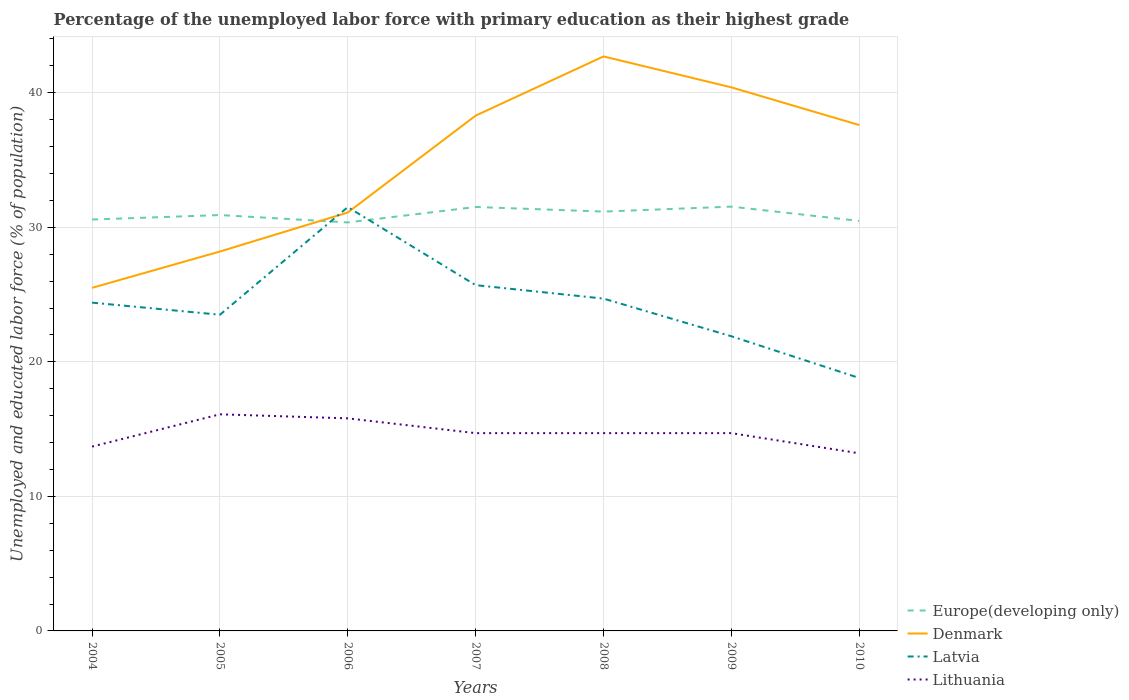How many different coloured lines are there?
Make the answer very short. 4. Does the line corresponding to Europe(developing only) intersect with the line corresponding to Latvia?
Your answer should be very brief. Yes. Across all years, what is the maximum percentage of the unemployed labor force with primary education in Europe(developing only)?
Provide a succinct answer. 30.36. In which year was the percentage of the unemployed labor force with primary education in Europe(developing only) maximum?
Provide a short and direct response. 2006. What is the total percentage of the unemployed labor force with primary education in Latvia in the graph?
Ensure brevity in your answer.  -0.3. What is the difference between the highest and the second highest percentage of the unemployed labor force with primary education in Europe(developing only)?
Offer a very short reply. 1.17. What is the difference between the highest and the lowest percentage of the unemployed labor force with primary education in Europe(developing only)?
Make the answer very short. 3. How many lines are there?
Offer a terse response. 4. How many years are there in the graph?
Provide a short and direct response. 7. What is the difference between two consecutive major ticks on the Y-axis?
Your answer should be compact. 10. Are the values on the major ticks of Y-axis written in scientific E-notation?
Offer a very short reply. No. Does the graph contain grids?
Your answer should be very brief. Yes. Where does the legend appear in the graph?
Your answer should be very brief. Bottom right. What is the title of the graph?
Your answer should be very brief. Percentage of the unemployed labor force with primary education as their highest grade. Does "Jordan" appear as one of the legend labels in the graph?
Your answer should be very brief. No. What is the label or title of the Y-axis?
Keep it short and to the point. Unemployed and educated labor force (% of population). What is the Unemployed and educated labor force (% of population) in Europe(developing only) in 2004?
Your answer should be compact. 30.58. What is the Unemployed and educated labor force (% of population) in Latvia in 2004?
Your answer should be compact. 24.4. What is the Unemployed and educated labor force (% of population) in Lithuania in 2004?
Provide a succinct answer. 13.7. What is the Unemployed and educated labor force (% of population) of Europe(developing only) in 2005?
Provide a short and direct response. 30.91. What is the Unemployed and educated labor force (% of population) of Denmark in 2005?
Offer a terse response. 28.2. What is the Unemployed and educated labor force (% of population) in Latvia in 2005?
Ensure brevity in your answer.  23.5. What is the Unemployed and educated labor force (% of population) in Lithuania in 2005?
Provide a short and direct response. 16.1. What is the Unemployed and educated labor force (% of population) in Europe(developing only) in 2006?
Keep it short and to the point. 30.36. What is the Unemployed and educated labor force (% of population) of Denmark in 2006?
Your response must be concise. 31.1. What is the Unemployed and educated labor force (% of population) of Latvia in 2006?
Your answer should be very brief. 31.5. What is the Unemployed and educated labor force (% of population) in Lithuania in 2006?
Provide a succinct answer. 15.8. What is the Unemployed and educated labor force (% of population) in Europe(developing only) in 2007?
Provide a succinct answer. 31.51. What is the Unemployed and educated labor force (% of population) of Denmark in 2007?
Keep it short and to the point. 38.3. What is the Unemployed and educated labor force (% of population) in Latvia in 2007?
Your answer should be very brief. 25.7. What is the Unemployed and educated labor force (% of population) of Lithuania in 2007?
Your response must be concise. 14.7. What is the Unemployed and educated labor force (% of population) of Europe(developing only) in 2008?
Provide a short and direct response. 31.17. What is the Unemployed and educated labor force (% of population) of Denmark in 2008?
Your answer should be very brief. 42.7. What is the Unemployed and educated labor force (% of population) in Latvia in 2008?
Keep it short and to the point. 24.7. What is the Unemployed and educated labor force (% of population) in Lithuania in 2008?
Keep it short and to the point. 14.7. What is the Unemployed and educated labor force (% of population) of Europe(developing only) in 2009?
Keep it short and to the point. 31.54. What is the Unemployed and educated labor force (% of population) in Denmark in 2009?
Your answer should be compact. 40.4. What is the Unemployed and educated labor force (% of population) in Latvia in 2009?
Your response must be concise. 21.9. What is the Unemployed and educated labor force (% of population) in Lithuania in 2009?
Your answer should be very brief. 14.7. What is the Unemployed and educated labor force (% of population) in Europe(developing only) in 2010?
Offer a very short reply. 30.47. What is the Unemployed and educated labor force (% of population) of Denmark in 2010?
Ensure brevity in your answer.  37.6. What is the Unemployed and educated labor force (% of population) in Latvia in 2010?
Offer a very short reply. 18.8. What is the Unemployed and educated labor force (% of population) in Lithuania in 2010?
Make the answer very short. 13.2. Across all years, what is the maximum Unemployed and educated labor force (% of population) in Europe(developing only)?
Ensure brevity in your answer.  31.54. Across all years, what is the maximum Unemployed and educated labor force (% of population) in Denmark?
Offer a very short reply. 42.7. Across all years, what is the maximum Unemployed and educated labor force (% of population) in Latvia?
Your answer should be very brief. 31.5. Across all years, what is the maximum Unemployed and educated labor force (% of population) in Lithuania?
Keep it short and to the point. 16.1. Across all years, what is the minimum Unemployed and educated labor force (% of population) of Europe(developing only)?
Your answer should be compact. 30.36. Across all years, what is the minimum Unemployed and educated labor force (% of population) of Denmark?
Provide a succinct answer. 25.5. Across all years, what is the minimum Unemployed and educated labor force (% of population) in Latvia?
Ensure brevity in your answer.  18.8. Across all years, what is the minimum Unemployed and educated labor force (% of population) in Lithuania?
Ensure brevity in your answer.  13.2. What is the total Unemployed and educated labor force (% of population) in Europe(developing only) in the graph?
Offer a terse response. 216.53. What is the total Unemployed and educated labor force (% of population) in Denmark in the graph?
Give a very brief answer. 243.8. What is the total Unemployed and educated labor force (% of population) in Latvia in the graph?
Make the answer very short. 170.5. What is the total Unemployed and educated labor force (% of population) in Lithuania in the graph?
Ensure brevity in your answer.  102.9. What is the difference between the Unemployed and educated labor force (% of population) of Europe(developing only) in 2004 and that in 2005?
Provide a succinct answer. -0.33. What is the difference between the Unemployed and educated labor force (% of population) in Latvia in 2004 and that in 2005?
Offer a very short reply. 0.9. What is the difference between the Unemployed and educated labor force (% of population) of Europe(developing only) in 2004 and that in 2006?
Provide a succinct answer. 0.22. What is the difference between the Unemployed and educated labor force (% of population) in Denmark in 2004 and that in 2006?
Your answer should be very brief. -5.6. What is the difference between the Unemployed and educated labor force (% of population) of Latvia in 2004 and that in 2006?
Offer a very short reply. -7.1. What is the difference between the Unemployed and educated labor force (% of population) in Lithuania in 2004 and that in 2006?
Your answer should be compact. -2.1. What is the difference between the Unemployed and educated labor force (% of population) of Europe(developing only) in 2004 and that in 2007?
Provide a succinct answer. -0.93. What is the difference between the Unemployed and educated labor force (% of population) of Lithuania in 2004 and that in 2007?
Your response must be concise. -1. What is the difference between the Unemployed and educated labor force (% of population) in Europe(developing only) in 2004 and that in 2008?
Your answer should be compact. -0.59. What is the difference between the Unemployed and educated labor force (% of population) in Denmark in 2004 and that in 2008?
Give a very brief answer. -17.2. What is the difference between the Unemployed and educated labor force (% of population) in Latvia in 2004 and that in 2008?
Provide a succinct answer. -0.3. What is the difference between the Unemployed and educated labor force (% of population) in Lithuania in 2004 and that in 2008?
Provide a succinct answer. -1. What is the difference between the Unemployed and educated labor force (% of population) in Europe(developing only) in 2004 and that in 2009?
Give a very brief answer. -0.96. What is the difference between the Unemployed and educated labor force (% of population) in Denmark in 2004 and that in 2009?
Make the answer very short. -14.9. What is the difference between the Unemployed and educated labor force (% of population) in Lithuania in 2004 and that in 2009?
Provide a succinct answer. -1. What is the difference between the Unemployed and educated labor force (% of population) in Europe(developing only) in 2004 and that in 2010?
Keep it short and to the point. 0.1. What is the difference between the Unemployed and educated labor force (% of population) of Lithuania in 2004 and that in 2010?
Offer a very short reply. 0.5. What is the difference between the Unemployed and educated labor force (% of population) in Europe(developing only) in 2005 and that in 2006?
Ensure brevity in your answer.  0.55. What is the difference between the Unemployed and educated labor force (% of population) of Denmark in 2005 and that in 2006?
Ensure brevity in your answer.  -2.9. What is the difference between the Unemployed and educated labor force (% of population) in Latvia in 2005 and that in 2006?
Your answer should be very brief. -8. What is the difference between the Unemployed and educated labor force (% of population) of Europe(developing only) in 2005 and that in 2007?
Your answer should be very brief. -0.6. What is the difference between the Unemployed and educated labor force (% of population) in Lithuania in 2005 and that in 2007?
Provide a succinct answer. 1.4. What is the difference between the Unemployed and educated labor force (% of population) of Europe(developing only) in 2005 and that in 2008?
Provide a succinct answer. -0.26. What is the difference between the Unemployed and educated labor force (% of population) of Denmark in 2005 and that in 2008?
Make the answer very short. -14.5. What is the difference between the Unemployed and educated labor force (% of population) of Europe(developing only) in 2005 and that in 2009?
Offer a very short reply. -0.63. What is the difference between the Unemployed and educated labor force (% of population) of Latvia in 2005 and that in 2009?
Offer a terse response. 1.6. What is the difference between the Unemployed and educated labor force (% of population) of Europe(developing only) in 2005 and that in 2010?
Your response must be concise. 0.44. What is the difference between the Unemployed and educated labor force (% of population) in Denmark in 2005 and that in 2010?
Your answer should be very brief. -9.4. What is the difference between the Unemployed and educated labor force (% of population) in Latvia in 2005 and that in 2010?
Give a very brief answer. 4.7. What is the difference between the Unemployed and educated labor force (% of population) of Lithuania in 2005 and that in 2010?
Provide a short and direct response. 2.9. What is the difference between the Unemployed and educated labor force (% of population) in Europe(developing only) in 2006 and that in 2007?
Offer a terse response. -1.15. What is the difference between the Unemployed and educated labor force (% of population) of Latvia in 2006 and that in 2007?
Make the answer very short. 5.8. What is the difference between the Unemployed and educated labor force (% of population) of Lithuania in 2006 and that in 2007?
Offer a terse response. 1.1. What is the difference between the Unemployed and educated labor force (% of population) of Europe(developing only) in 2006 and that in 2008?
Provide a succinct answer. -0.81. What is the difference between the Unemployed and educated labor force (% of population) in Denmark in 2006 and that in 2008?
Make the answer very short. -11.6. What is the difference between the Unemployed and educated labor force (% of population) in Latvia in 2006 and that in 2008?
Your response must be concise. 6.8. What is the difference between the Unemployed and educated labor force (% of population) in Europe(developing only) in 2006 and that in 2009?
Make the answer very short. -1.17. What is the difference between the Unemployed and educated labor force (% of population) of Latvia in 2006 and that in 2009?
Provide a succinct answer. 9.6. What is the difference between the Unemployed and educated labor force (% of population) of Lithuania in 2006 and that in 2009?
Ensure brevity in your answer.  1.1. What is the difference between the Unemployed and educated labor force (% of population) in Europe(developing only) in 2006 and that in 2010?
Offer a very short reply. -0.11. What is the difference between the Unemployed and educated labor force (% of population) in Europe(developing only) in 2007 and that in 2008?
Give a very brief answer. 0.34. What is the difference between the Unemployed and educated labor force (% of population) in Lithuania in 2007 and that in 2008?
Offer a terse response. 0. What is the difference between the Unemployed and educated labor force (% of population) in Europe(developing only) in 2007 and that in 2009?
Offer a very short reply. -0.03. What is the difference between the Unemployed and educated labor force (% of population) of Denmark in 2007 and that in 2009?
Provide a short and direct response. -2.1. What is the difference between the Unemployed and educated labor force (% of population) of Latvia in 2007 and that in 2009?
Your response must be concise. 3.8. What is the difference between the Unemployed and educated labor force (% of population) of Lithuania in 2007 and that in 2009?
Give a very brief answer. 0. What is the difference between the Unemployed and educated labor force (% of population) of Europe(developing only) in 2007 and that in 2010?
Make the answer very short. 1.04. What is the difference between the Unemployed and educated labor force (% of population) of Lithuania in 2007 and that in 2010?
Give a very brief answer. 1.5. What is the difference between the Unemployed and educated labor force (% of population) of Europe(developing only) in 2008 and that in 2009?
Keep it short and to the point. -0.37. What is the difference between the Unemployed and educated labor force (% of population) in Lithuania in 2008 and that in 2009?
Keep it short and to the point. 0. What is the difference between the Unemployed and educated labor force (% of population) of Europe(developing only) in 2008 and that in 2010?
Give a very brief answer. 0.69. What is the difference between the Unemployed and educated labor force (% of population) in Latvia in 2008 and that in 2010?
Provide a short and direct response. 5.9. What is the difference between the Unemployed and educated labor force (% of population) in Lithuania in 2008 and that in 2010?
Give a very brief answer. 1.5. What is the difference between the Unemployed and educated labor force (% of population) in Europe(developing only) in 2009 and that in 2010?
Ensure brevity in your answer.  1.06. What is the difference between the Unemployed and educated labor force (% of population) of Lithuania in 2009 and that in 2010?
Provide a succinct answer. 1.5. What is the difference between the Unemployed and educated labor force (% of population) of Europe(developing only) in 2004 and the Unemployed and educated labor force (% of population) of Denmark in 2005?
Your answer should be very brief. 2.38. What is the difference between the Unemployed and educated labor force (% of population) in Europe(developing only) in 2004 and the Unemployed and educated labor force (% of population) in Latvia in 2005?
Offer a terse response. 7.08. What is the difference between the Unemployed and educated labor force (% of population) in Europe(developing only) in 2004 and the Unemployed and educated labor force (% of population) in Lithuania in 2005?
Provide a short and direct response. 14.48. What is the difference between the Unemployed and educated labor force (% of population) of Denmark in 2004 and the Unemployed and educated labor force (% of population) of Lithuania in 2005?
Ensure brevity in your answer.  9.4. What is the difference between the Unemployed and educated labor force (% of population) of Europe(developing only) in 2004 and the Unemployed and educated labor force (% of population) of Denmark in 2006?
Offer a very short reply. -0.52. What is the difference between the Unemployed and educated labor force (% of population) of Europe(developing only) in 2004 and the Unemployed and educated labor force (% of population) of Latvia in 2006?
Keep it short and to the point. -0.92. What is the difference between the Unemployed and educated labor force (% of population) in Europe(developing only) in 2004 and the Unemployed and educated labor force (% of population) in Lithuania in 2006?
Ensure brevity in your answer.  14.78. What is the difference between the Unemployed and educated labor force (% of population) of Denmark in 2004 and the Unemployed and educated labor force (% of population) of Latvia in 2006?
Your response must be concise. -6. What is the difference between the Unemployed and educated labor force (% of population) of Denmark in 2004 and the Unemployed and educated labor force (% of population) of Lithuania in 2006?
Provide a short and direct response. 9.7. What is the difference between the Unemployed and educated labor force (% of population) in Europe(developing only) in 2004 and the Unemployed and educated labor force (% of population) in Denmark in 2007?
Give a very brief answer. -7.72. What is the difference between the Unemployed and educated labor force (% of population) of Europe(developing only) in 2004 and the Unemployed and educated labor force (% of population) of Latvia in 2007?
Provide a short and direct response. 4.88. What is the difference between the Unemployed and educated labor force (% of population) of Europe(developing only) in 2004 and the Unemployed and educated labor force (% of population) of Lithuania in 2007?
Your answer should be very brief. 15.88. What is the difference between the Unemployed and educated labor force (% of population) in Denmark in 2004 and the Unemployed and educated labor force (% of population) in Latvia in 2007?
Keep it short and to the point. -0.2. What is the difference between the Unemployed and educated labor force (% of population) in Denmark in 2004 and the Unemployed and educated labor force (% of population) in Lithuania in 2007?
Your answer should be very brief. 10.8. What is the difference between the Unemployed and educated labor force (% of population) of Latvia in 2004 and the Unemployed and educated labor force (% of population) of Lithuania in 2007?
Keep it short and to the point. 9.7. What is the difference between the Unemployed and educated labor force (% of population) of Europe(developing only) in 2004 and the Unemployed and educated labor force (% of population) of Denmark in 2008?
Ensure brevity in your answer.  -12.12. What is the difference between the Unemployed and educated labor force (% of population) of Europe(developing only) in 2004 and the Unemployed and educated labor force (% of population) of Latvia in 2008?
Provide a short and direct response. 5.88. What is the difference between the Unemployed and educated labor force (% of population) of Europe(developing only) in 2004 and the Unemployed and educated labor force (% of population) of Lithuania in 2008?
Your response must be concise. 15.88. What is the difference between the Unemployed and educated labor force (% of population) of Europe(developing only) in 2004 and the Unemployed and educated labor force (% of population) of Denmark in 2009?
Your answer should be very brief. -9.82. What is the difference between the Unemployed and educated labor force (% of population) of Europe(developing only) in 2004 and the Unemployed and educated labor force (% of population) of Latvia in 2009?
Provide a short and direct response. 8.68. What is the difference between the Unemployed and educated labor force (% of population) of Europe(developing only) in 2004 and the Unemployed and educated labor force (% of population) of Lithuania in 2009?
Give a very brief answer. 15.88. What is the difference between the Unemployed and educated labor force (% of population) in Europe(developing only) in 2004 and the Unemployed and educated labor force (% of population) in Denmark in 2010?
Your answer should be very brief. -7.02. What is the difference between the Unemployed and educated labor force (% of population) in Europe(developing only) in 2004 and the Unemployed and educated labor force (% of population) in Latvia in 2010?
Your answer should be very brief. 11.78. What is the difference between the Unemployed and educated labor force (% of population) of Europe(developing only) in 2004 and the Unemployed and educated labor force (% of population) of Lithuania in 2010?
Offer a terse response. 17.38. What is the difference between the Unemployed and educated labor force (% of population) in Denmark in 2004 and the Unemployed and educated labor force (% of population) in Latvia in 2010?
Give a very brief answer. 6.7. What is the difference between the Unemployed and educated labor force (% of population) of Europe(developing only) in 2005 and the Unemployed and educated labor force (% of population) of Denmark in 2006?
Offer a terse response. -0.19. What is the difference between the Unemployed and educated labor force (% of population) of Europe(developing only) in 2005 and the Unemployed and educated labor force (% of population) of Latvia in 2006?
Offer a very short reply. -0.59. What is the difference between the Unemployed and educated labor force (% of population) of Europe(developing only) in 2005 and the Unemployed and educated labor force (% of population) of Lithuania in 2006?
Your response must be concise. 15.11. What is the difference between the Unemployed and educated labor force (% of population) of Europe(developing only) in 2005 and the Unemployed and educated labor force (% of population) of Denmark in 2007?
Provide a succinct answer. -7.39. What is the difference between the Unemployed and educated labor force (% of population) in Europe(developing only) in 2005 and the Unemployed and educated labor force (% of population) in Latvia in 2007?
Your response must be concise. 5.21. What is the difference between the Unemployed and educated labor force (% of population) of Europe(developing only) in 2005 and the Unemployed and educated labor force (% of population) of Lithuania in 2007?
Your response must be concise. 16.21. What is the difference between the Unemployed and educated labor force (% of population) of Denmark in 2005 and the Unemployed and educated labor force (% of population) of Latvia in 2007?
Provide a succinct answer. 2.5. What is the difference between the Unemployed and educated labor force (% of population) in Latvia in 2005 and the Unemployed and educated labor force (% of population) in Lithuania in 2007?
Make the answer very short. 8.8. What is the difference between the Unemployed and educated labor force (% of population) of Europe(developing only) in 2005 and the Unemployed and educated labor force (% of population) of Denmark in 2008?
Provide a succinct answer. -11.79. What is the difference between the Unemployed and educated labor force (% of population) of Europe(developing only) in 2005 and the Unemployed and educated labor force (% of population) of Latvia in 2008?
Keep it short and to the point. 6.21. What is the difference between the Unemployed and educated labor force (% of population) of Europe(developing only) in 2005 and the Unemployed and educated labor force (% of population) of Lithuania in 2008?
Keep it short and to the point. 16.21. What is the difference between the Unemployed and educated labor force (% of population) of Denmark in 2005 and the Unemployed and educated labor force (% of population) of Latvia in 2008?
Give a very brief answer. 3.5. What is the difference between the Unemployed and educated labor force (% of population) of Denmark in 2005 and the Unemployed and educated labor force (% of population) of Lithuania in 2008?
Your response must be concise. 13.5. What is the difference between the Unemployed and educated labor force (% of population) in Europe(developing only) in 2005 and the Unemployed and educated labor force (% of population) in Denmark in 2009?
Keep it short and to the point. -9.49. What is the difference between the Unemployed and educated labor force (% of population) in Europe(developing only) in 2005 and the Unemployed and educated labor force (% of population) in Latvia in 2009?
Your response must be concise. 9.01. What is the difference between the Unemployed and educated labor force (% of population) of Europe(developing only) in 2005 and the Unemployed and educated labor force (% of population) of Lithuania in 2009?
Give a very brief answer. 16.21. What is the difference between the Unemployed and educated labor force (% of population) in Denmark in 2005 and the Unemployed and educated labor force (% of population) in Latvia in 2009?
Your answer should be very brief. 6.3. What is the difference between the Unemployed and educated labor force (% of population) of Denmark in 2005 and the Unemployed and educated labor force (% of population) of Lithuania in 2009?
Make the answer very short. 13.5. What is the difference between the Unemployed and educated labor force (% of population) in Europe(developing only) in 2005 and the Unemployed and educated labor force (% of population) in Denmark in 2010?
Your answer should be very brief. -6.69. What is the difference between the Unemployed and educated labor force (% of population) of Europe(developing only) in 2005 and the Unemployed and educated labor force (% of population) of Latvia in 2010?
Offer a terse response. 12.11. What is the difference between the Unemployed and educated labor force (% of population) in Europe(developing only) in 2005 and the Unemployed and educated labor force (% of population) in Lithuania in 2010?
Your answer should be compact. 17.71. What is the difference between the Unemployed and educated labor force (% of population) of Europe(developing only) in 2006 and the Unemployed and educated labor force (% of population) of Denmark in 2007?
Give a very brief answer. -7.94. What is the difference between the Unemployed and educated labor force (% of population) in Europe(developing only) in 2006 and the Unemployed and educated labor force (% of population) in Latvia in 2007?
Offer a terse response. 4.66. What is the difference between the Unemployed and educated labor force (% of population) of Europe(developing only) in 2006 and the Unemployed and educated labor force (% of population) of Lithuania in 2007?
Provide a succinct answer. 15.66. What is the difference between the Unemployed and educated labor force (% of population) in Denmark in 2006 and the Unemployed and educated labor force (% of population) in Latvia in 2007?
Keep it short and to the point. 5.4. What is the difference between the Unemployed and educated labor force (% of population) in Denmark in 2006 and the Unemployed and educated labor force (% of population) in Lithuania in 2007?
Offer a very short reply. 16.4. What is the difference between the Unemployed and educated labor force (% of population) in Europe(developing only) in 2006 and the Unemployed and educated labor force (% of population) in Denmark in 2008?
Offer a terse response. -12.34. What is the difference between the Unemployed and educated labor force (% of population) of Europe(developing only) in 2006 and the Unemployed and educated labor force (% of population) of Latvia in 2008?
Provide a short and direct response. 5.66. What is the difference between the Unemployed and educated labor force (% of population) in Europe(developing only) in 2006 and the Unemployed and educated labor force (% of population) in Lithuania in 2008?
Your answer should be compact. 15.66. What is the difference between the Unemployed and educated labor force (% of population) in Denmark in 2006 and the Unemployed and educated labor force (% of population) in Latvia in 2008?
Make the answer very short. 6.4. What is the difference between the Unemployed and educated labor force (% of population) of Denmark in 2006 and the Unemployed and educated labor force (% of population) of Lithuania in 2008?
Offer a terse response. 16.4. What is the difference between the Unemployed and educated labor force (% of population) in Europe(developing only) in 2006 and the Unemployed and educated labor force (% of population) in Denmark in 2009?
Make the answer very short. -10.04. What is the difference between the Unemployed and educated labor force (% of population) of Europe(developing only) in 2006 and the Unemployed and educated labor force (% of population) of Latvia in 2009?
Your answer should be compact. 8.46. What is the difference between the Unemployed and educated labor force (% of population) in Europe(developing only) in 2006 and the Unemployed and educated labor force (% of population) in Lithuania in 2009?
Your response must be concise. 15.66. What is the difference between the Unemployed and educated labor force (% of population) of Denmark in 2006 and the Unemployed and educated labor force (% of population) of Latvia in 2009?
Provide a succinct answer. 9.2. What is the difference between the Unemployed and educated labor force (% of population) in Denmark in 2006 and the Unemployed and educated labor force (% of population) in Lithuania in 2009?
Ensure brevity in your answer.  16.4. What is the difference between the Unemployed and educated labor force (% of population) in Latvia in 2006 and the Unemployed and educated labor force (% of population) in Lithuania in 2009?
Make the answer very short. 16.8. What is the difference between the Unemployed and educated labor force (% of population) in Europe(developing only) in 2006 and the Unemployed and educated labor force (% of population) in Denmark in 2010?
Offer a very short reply. -7.24. What is the difference between the Unemployed and educated labor force (% of population) of Europe(developing only) in 2006 and the Unemployed and educated labor force (% of population) of Latvia in 2010?
Keep it short and to the point. 11.56. What is the difference between the Unemployed and educated labor force (% of population) in Europe(developing only) in 2006 and the Unemployed and educated labor force (% of population) in Lithuania in 2010?
Give a very brief answer. 17.16. What is the difference between the Unemployed and educated labor force (% of population) of Denmark in 2006 and the Unemployed and educated labor force (% of population) of Latvia in 2010?
Ensure brevity in your answer.  12.3. What is the difference between the Unemployed and educated labor force (% of population) of Denmark in 2006 and the Unemployed and educated labor force (% of population) of Lithuania in 2010?
Offer a very short reply. 17.9. What is the difference between the Unemployed and educated labor force (% of population) in Latvia in 2006 and the Unemployed and educated labor force (% of population) in Lithuania in 2010?
Your answer should be compact. 18.3. What is the difference between the Unemployed and educated labor force (% of population) in Europe(developing only) in 2007 and the Unemployed and educated labor force (% of population) in Denmark in 2008?
Provide a succinct answer. -11.19. What is the difference between the Unemployed and educated labor force (% of population) in Europe(developing only) in 2007 and the Unemployed and educated labor force (% of population) in Latvia in 2008?
Your answer should be compact. 6.81. What is the difference between the Unemployed and educated labor force (% of population) of Europe(developing only) in 2007 and the Unemployed and educated labor force (% of population) of Lithuania in 2008?
Your answer should be compact. 16.81. What is the difference between the Unemployed and educated labor force (% of population) of Denmark in 2007 and the Unemployed and educated labor force (% of population) of Latvia in 2008?
Provide a succinct answer. 13.6. What is the difference between the Unemployed and educated labor force (% of population) in Denmark in 2007 and the Unemployed and educated labor force (% of population) in Lithuania in 2008?
Give a very brief answer. 23.6. What is the difference between the Unemployed and educated labor force (% of population) of Europe(developing only) in 2007 and the Unemployed and educated labor force (% of population) of Denmark in 2009?
Your response must be concise. -8.89. What is the difference between the Unemployed and educated labor force (% of population) of Europe(developing only) in 2007 and the Unemployed and educated labor force (% of population) of Latvia in 2009?
Offer a terse response. 9.61. What is the difference between the Unemployed and educated labor force (% of population) in Europe(developing only) in 2007 and the Unemployed and educated labor force (% of population) in Lithuania in 2009?
Give a very brief answer. 16.81. What is the difference between the Unemployed and educated labor force (% of population) in Denmark in 2007 and the Unemployed and educated labor force (% of population) in Lithuania in 2009?
Provide a short and direct response. 23.6. What is the difference between the Unemployed and educated labor force (% of population) in Latvia in 2007 and the Unemployed and educated labor force (% of population) in Lithuania in 2009?
Provide a succinct answer. 11. What is the difference between the Unemployed and educated labor force (% of population) in Europe(developing only) in 2007 and the Unemployed and educated labor force (% of population) in Denmark in 2010?
Provide a short and direct response. -6.09. What is the difference between the Unemployed and educated labor force (% of population) of Europe(developing only) in 2007 and the Unemployed and educated labor force (% of population) of Latvia in 2010?
Ensure brevity in your answer.  12.71. What is the difference between the Unemployed and educated labor force (% of population) in Europe(developing only) in 2007 and the Unemployed and educated labor force (% of population) in Lithuania in 2010?
Ensure brevity in your answer.  18.31. What is the difference between the Unemployed and educated labor force (% of population) of Denmark in 2007 and the Unemployed and educated labor force (% of population) of Latvia in 2010?
Provide a short and direct response. 19.5. What is the difference between the Unemployed and educated labor force (% of population) in Denmark in 2007 and the Unemployed and educated labor force (% of population) in Lithuania in 2010?
Make the answer very short. 25.1. What is the difference between the Unemployed and educated labor force (% of population) in Europe(developing only) in 2008 and the Unemployed and educated labor force (% of population) in Denmark in 2009?
Your response must be concise. -9.23. What is the difference between the Unemployed and educated labor force (% of population) in Europe(developing only) in 2008 and the Unemployed and educated labor force (% of population) in Latvia in 2009?
Make the answer very short. 9.27. What is the difference between the Unemployed and educated labor force (% of population) in Europe(developing only) in 2008 and the Unemployed and educated labor force (% of population) in Lithuania in 2009?
Your answer should be compact. 16.47. What is the difference between the Unemployed and educated labor force (% of population) in Denmark in 2008 and the Unemployed and educated labor force (% of population) in Latvia in 2009?
Provide a short and direct response. 20.8. What is the difference between the Unemployed and educated labor force (% of population) of Europe(developing only) in 2008 and the Unemployed and educated labor force (% of population) of Denmark in 2010?
Your answer should be compact. -6.43. What is the difference between the Unemployed and educated labor force (% of population) of Europe(developing only) in 2008 and the Unemployed and educated labor force (% of population) of Latvia in 2010?
Provide a succinct answer. 12.37. What is the difference between the Unemployed and educated labor force (% of population) of Europe(developing only) in 2008 and the Unemployed and educated labor force (% of population) of Lithuania in 2010?
Your answer should be very brief. 17.97. What is the difference between the Unemployed and educated labor force (% of population) in Denmark in 2008 and the Unemployed and educated labor force (% of population) in Latvia in 2010?
Ensure brevity in your answer.  23.9. What is the difference between the Unemployed and educated labor force (% of population) in Denmark in 2008 and the Unemployed and educated labor force (% of population) in Lithuania in 2010?
Provide a succinct answer. 29.5. What is the difference between the Unemployed and educated labor force (% of population) of Latvia in 2008 and the Unemployed and educated labor force (% of population) of Lithuania in 2010?
Provide a succinct answer. 11.5. What is the difference between the Unemployed and educated labor force (% of population) in Europe(developing only) in 2009 and the Unemployed and educated labor force (% of population) in Denmark in 2010?
Ensure brevity in your answer.  -6.06. What is the difference between the Unemployed and educated labor force (% of population) of Europe(developing only) in 2009 and the Unemployed and educated labor force (% of population) of Latvia in 2010?
Give a very brief answer. 12.74. What is the difference between the Unemployed and educated labor force (% of population) in Europe(developing only) in 2009 and the Unemployed and educated labor force (% of population) in Lithuania in 2010?
Provide a short and direct response. 18.34. What is the difference between the Unemployed and educated labor force (% of population) in Denmark in 2009 and the Unemployed and educated labor force (% of population) in Latvia in 2010?
Your answer should be compact. 21.6. What is the difference between the Unemployed and educated labor force (% of population) of Denmark in 2009 and the Unemployed and educated labor force (% of population) of Lithuania in 2010?
Ensure brevity in your answer.  27.2. What is the average Unemployed and educated labor force (% of population) of Europe(developing only) per year?
Your response must be concise. 30.93. What is the average Unemployed and educated labor force (% of population) of Denmark per year?
Ensure brevity in your answer.  34.83. What is the average Unemployed and educated labor force (% of population) in Latvia per year?
Offer a terse response. 24.36. What is the average Unemployed and educated labor force (% of population) in Lithuania per year?
Your answer should be very brief. 14.7. In the year 2004, what is the difference between the Unemployed and educated labor force (% of population) of Europe(developing only) and Unemployed and educated labor force (% of population) of Denmark?
Make the answer very short. 5.08. In the year 2004, what is the difference between the Unemployed and educated labor force (% of population) in Europe(developing only) and Unemployed and educated labor force (% of population) in Latvia?
Provide a short and direct response. 6.18. In the year 2004, what is the difference between the Unemployed and educated labor force (% of population) of Europe(developing only) and Unemployed and educated labor force (% of population) of Lithuania?
Give a very brief answer. 16.88. In the year 2004, what is the difference between the Unemployed and educated labor force (% of population) of Latvia and Unemployed and educated labor force (% of population) of Lithuania?
Your answer should be compact. 10.7. In the year 2005, what is the difference between the Unemployed and educated labor force (% of population) in Europe(developing only) and Unemployed and educated labor force (% of population) in Denmark?
Provide a succinct answer. 2.71. In the year 2005, what is the difference between the Unemployed and educated labor force (% of population) of Europe(developing only) and Unemployed and educated labor force (% of population) of Latvia?
Your answer should be very brief. 7.41. In the year 2005, what is the difference between the Unemployed and educated labor force (% of population) in Europe(developing only) and Unemployed and educated labor force (% of population) in Lithuania?
Make the answer very short. 14.81. In the year 2005, what is the difference between the Unemployed and educated labor force (% of population) of Denmark and Unemployed and educated labor force (% of population) of Lithuania?
Provide a succinct answer. 12.1. In the year 2006, what is the difference between the Unemployed and educated labor force (% of population) of Europe(developing only) and Unemployed and educated labor force (% of population) of Denmark?
Ensure brevity in your answer.  -0.74. In the year 2006, what is the difference between the Unemployed and educated labor force (% of population) of Europe(developing only) and Unemployed and educated labor force (% of population) of Latvia?
Keep it short and to the point. -1.14. In the year 2006, what is the difference between the Unemployed and educated labor force (% of population) in Europe(developing only) and Unemployed and educated labor force (% of population) in Lithuania?
Make the answer very short. 14.56. In the year 2006, what is the difference between the Unemployed and educated labor force (% of population) of Denmark and Unemployed and educated labor force (% of population) of Latvia?
Give a very brief answer. -0.4. In the year 2006, what is the difference between the Unemployed and educated labor force (% of population) of Latvia and Unemployed and educated labor force (% of population) of Lithuania?
Give a very brief answer. 15.7. In the year 2007, what is the difference between the Unemployed and educated labor force (% of population) in Europe(developing only) and Unemployed and educated labor force (% of population) in Denmark?
Give a very brief answer. -6.79. In the year 2007, what is the difference between the Unemployed and educated labor force (% of population) in Europe(developing only) and Unemployed and educated labor force (% of population) in Latvia?
Provide a succinct answer. 5.81. In the year 2007, what is the difference between the Unemployed and educated labor force (% of population) in Europe(developing only) and Unemployed and educated labor force (% of population) in Lithuania?
Give a very brief answer. 16.81. In the year 2007, what is the difference between the Unemployed and educated labor force (% of population) of Denmark and Unemployed and educated labor force (% of population) of Lithuania?
Ensure brevity in your answer.  23.6. In the year 2008, what is the difference between the Unemployed and educated labor force (% of population) of Europe(developing only) and Unemployed and educated labor force (% of population) of Denmark?
Provide a short and direct response. -11.53. In the year 2008, what is the difference between the Unemployed and educated labor force (% of population) of Europe(developing only) and Unemployed and educated labor force (% of population) of Latvia?
Provide a succinct answer. 6.47. In the year 2008, what is the difference between the Unemployed and educated labor force (% of population) in Europe(developing only) and Unemployed and educated labor force (% of population) in Lithuania?
Offer a very short reply. 16.47. In the year 2008, what is the difference between the Unemployed and educated labor force (% of population) of Denmark and Unemployed and educated labor force (% of population) of Latvia?
Provide a succinct answer. 18. In the year 2008, what is the difference between the Unemployed and educated labor force (% of population) of Denmark and Unemployed and educated labor force (% of population) of Lithuania?
Offer a very short reply. 28. In the year 2009, what is the difference between the Unemployed and educated labor force (% of population) in Europe(developing only) and Unemployed and educated labor force (% of population) in Denmark?
Ensure brevity in your answer.  -8.86. In the year 2009, what is the difference between the Unemployed and educated labor force (% of population) of Europe(developing only) and Unemployed and educated labor force (% of population) of Latvia?
Make the answer very short. 9.64. In the year 2009, what is the difference between the Unemployed and educated labor force (% of population) in Europe(developing only) and Unemployed and educated labor force (% of population) in Lithuania?
Your answer should be compact. 16.84. In the year 2009, what is the difference between the Unemployed and educated labor force (% of population) in Denmark and Unemployed and educated labor force (% of population) in Lithuania?
Provide a succinct answer. 25.7. In the year 2009, what is the difference between the Unemployed and educated labor force (% of population) in Latvia and Unemployed and educated labor force (% of population) in Lithuania?
Make the answer very short. 7.2. In the year 2010, what is the difference between the Unemployed and educated labor force (% of population) in Europe(developing only) and Unemployed and educated labor force (% of population) in Denmark?
Provide a succinct answer. -7.13. In the year 2010, what is the difference between the Unemployed and educated labor force (% of population) in Europe(developing only) and Unemployed and educated labor force (% of population) in Latvia?
Give a very brief answer. 11.67. In the year 2010, what is the difference between the Unemployed and educated labor force (% of population) in Europe(developing only) and Unemployed and educated labor force (% of population) in Lithuania?
Give a very brief answer. 17.27. In the year 2010, what is the difference between the Unemployed and educated labor force (% of population) of Denmark and Unemployed and educated labor force (% of population) of Lithuania?
Your answer should be compact. 24.4. What is the ratio of the Unemployed and educated labor force (% of population) in Europe(developing only) in 2004 to that in 2005?
Ensure brevity in your answer.  0.99. What is the ratio of the Unemployed and educated labor force (% of population) of Denmark in 2004 to that in 2005?
Your answer should be very brief. 0.9. What is the ratio of the Unemployed and educated labor force (% of population) in Latvia in 2004 to that in 2005?
Ensure brevity in your answer.  1.04. What is the ratio of the Unemployed and educated labor force (% of population) in Lithuania in 2004 to that in 2005?
Provide a succinct answer. 0.85. What is the ratio of the Unemployed and educated labor force (% of population) of Europe(developing only) in 2004 to that in 2006?
Give a very brief answer. 1.01. What is the ratio of the Unemployed and educated labor force (% of population) in Denmark in 2004 to that in 2006?
Provide a short and direct response. 0.82. What is the ratio of the Unemployed and educated labor force (% of population) of Latvia in 2004 to that in 2006?
Provide a succinct answer. 0.77. What is the ratio of the Unemployed and educated labor force (% of population) in Lithuania in 2004 to that in 2006?
Your answer should be very brief. 0.87. What is the ratio of the Unemployed and educated labor force (% of population) of Europe(developing only) in 2004 to that in 2007?
Ensure brevity in your answer.  0.97. What is the ratio of the Unemployed and educated labor force (% of population) in Denmark in 2004 to that in 2007?
Offer a very short reply. 0.67. What is the ratio of the Unemployed and educated labor force (% of population) of Latvia in 2004 to that in 2007?
Provide a short and direct response. 0.95. What is the ratio of the Unemployed and educated labor force (% of population) in Lithuania in 2004 to that in 2007?
Make the answer very short. 0.93. What is the ratio of the Unemployed and educated labor force (% of population) in Europe(developing only) in 2004 to that in 2008?
Ensure brevity in your answer.  0.98. What is the ratio of the Unemployed and educated labor force (% of population) in Denmark in 2004 to that in 2008?
Your answer should be compact. 0.6. What is the ratio of the Unemployed and educated labor force (% of population) of Latvia in 2004 to that in 2008?
Your response must be concise. 0.99. What is the ratio of the Unemployed and educated labor force (% of population) in Lithuania in 2004 to that in 2008?
Ensure brevity in your answer.  0.93. What is the ratio of the Unemployed and educated labor force (% of population) of Europe(developing only) in 2004 to that in 2009?
Provide a short and direct response. 0.97. What is the ratio of the Unemployed and educated labor force (% of population) of Denmark in 2004 to that in 2009?
Offer a very short reply. 0.63. What is the ratio of the Unemployed and educated labor force (% of population) of Latvia in 2004 to that in 2009?
Ensure brevity in your answer.  1.11. What is the ratio of the Unemployed and educated labor force (% of population) of Lithuania in 2004 to that in 2009?
Keep it short and to the point. 0.93. What is the ratio of the Unemployed and educated labor force (% of population) in Europe(developing only) in 2004 to that in 2010?
Offer a very short reply. 1. What is the ratio of the Unemployed and educated labor force (% of population) in Denmark in 2004 to that in 2010?
Offer a terse response. 0.68. What is the ratio of the Unemployed and educated labor force (% of population) in Latvia in 2004 to that in 2010?
Your response must be concise. 1.3. What is the ratio of the Unemployed and educated labor force (% of population) in Lithuania in 2004 to that in 2010?
Your response must be concise. 1.04. What is the ratio of the Unemployed and educated labor force (% of population) of Europe(developing only) in 2005 to that in 2006?
Your answer should be very brief. 1.02. What is the ratio of the Unemployed and educated labor force (% of population) in Denmark in 2005 to that in 2006?
Offer a terse response. 0.91. What is the ratio of the Unemployed and educated labor force (% of population) in Latvia in 2005 to that in 2006?
Offer a terse response. 0.75. What is the ratio of the Unemployed and educated labor force (% of population) of Denmark in 2005 to that in 2007?
Give a very brief answer. 0.74. What is the ratio of the Unemployed and educated labor force (% of population) of Latvia in 2005 to that in 2007?
Your response must be concise. 0.91. What is the ratio of the Unemployed and educated labor force (% of population) of Lithuania in 2005 to that in 2007?
Make the answer very short. 1.1. What is the ratio of the Unemployed and educated labor force (% of population) of Denmark in 2005 to that in 2008?
Ensure brevity in your answer.  0.66. What is the ratio of the Unemployed and educated labor force (% of population) in Latvia in 2005 to that in 2008?
Ensure brevity in your answer.  0.95. What is the ratio of the Unemployed and educated labor force (% of population) in Lithuania in 2005 to that in 2008?
Your answer should be very brief. 1.1. What is the ratio of the Unemployed and educated labor force (% of population) in Europe(developing only) in 2005 to that in 2009?
Provide a succinct answer. 0.98. What is the ratio of the Unemployed and educated labor force (% of population) of Denmark in 2005 to that in 2009?
Ensure brevity in your answer.  0.7. What is the ratio of the Unemployed and educated labor force (% of population) of Latvia in 2005 to that in 2009?
Offer a very short reply. 1.07. What is the ratio of the Unemployed and educated labor force (% of population) in Lithuania in 2005 to that in 2009?
Ensure brevity in your answer.  1.1. What is the ratio of the Unemployed and educated labor force (% of population) of Europe(developing only) in 2005 to that in 2010?
Ensure brevity in your answer.  1.01. What is the ratio of the Unemployed and educated labor force (% of population) of Denmark in 2005 to that in 2010?
Provide a short and direct response. 0.75. What is the ratio of the Unemployed and educated labor force (% of population) in Latvia in 2005 to that in 2010?
Offer a terse response. 1.25. What is the ratio of the Unemployed and educated labor force (% of population) in Lithuania in 2005 to that in 2010?
Your answer should be very brief. 1.22. What is the ratio of the Unemployed and educated labor force (% of population) in Europe(developing only) in 2006 to that in 2007?
Make the answer very short. 0.96. What is the ratio of the Unemployed and educated labor force (% of population) of Denmark in 2006 to that in 2007?
Offer a very short reply. 0.81. What is the ratio of the Unemployed and educated labor force (% of population) of Latvia in 2006 to that in 2007?
Offer a terse response. 1.23. What is the ratio of the Unemployed and educated labor force (% of population) in Lithuania in 2006 to that in 2007?
Provide a succinct answer. 1.07. What is the ratio of the Unemployed and educated labor force (% of population) in Europe(developing only) in 2006 to that in 2008?
Your response must be concise. 0.97. What is the ratio of the Unemployed and educated labor force (% of population) of Denmark in 2006 to that in 2008?
Provide a succinct answer. 0.73. What is the ratio of the Unemployed and educated labor force (% of population) of Latvia in 2006 to that in 2008?
Provide a succinct answer. 1.28. What is the ratio of the Unemployed and educated labor force (% of population) in Lithuania in 2006 to that in 2008?
Keep it short and to the point. 1.07. What is the ratio of the Unemployed and educated labor force (% of population) of Europe(developing only) in 2006 to that in 2009?
Your answer should be compact. 0.96. What is the ratio of the Unemployed and educated labor force (% of population) of Denmark in 2006 to that in 2009?
Offer a very short reply. 0.77. What is the ratio of the Unemployed and educated labor force (% of population) of Latvia in 2006 to that in 2009?
Make the answer very short. 1.44. What is the ratio of the Unemployed and educated labor force (% of population) in Lithuania in 2006 to that in 2009?
Provide a short and direct response. 1.07. What is the ratio of the Unemployed and educated labor force (% of population) of Denmark in 2006 to that in 2010?
Your answer should be compact. 0.83. What is the ratio of the Unemployed and educated labor force (% of population) of Latvia in 2006 to that in 2010?
Offer a terse response. 1.68. What is the ratio of the Unemployed and educated labor force (% of population) in Lithuania in 2006 to that in 2010?
Make the answer very short. 1.2. What is the ratio of the Unemployed and educated labor force (% of population) of Europe(developing only) in 2007 to that in 2008?
Provide a succinct answer. 1.01. What is the ratio of the Unemployed and educated labor force (% of population) in Denmark in 2007 to that in 2008?
Make the answer very short. 0.9. What is the ratio of the Unemployed and educated labor force (% of population) in Latvia in 2007 to that in 2008?
Your response must be concise. 1.04. What is the ratio of the Unemployed and educated labor force (% of population) in Europe(developing only) in 2007 to that in 2009?
Offer a very short reply. 1. What is the ratio of the Unemployed and educated labor force (% of population) of Denmark in 2007 to that in 2009?
Provide a short and direct response. 0.95. What is the ratio of the Unemployed and educated labor force (% of population) of Latvia in 2007 to that in 2009?
Offer a very short reply. 1.17. What is the ratio of the Unemployed and educated labor force (% of population) of Europe(developing only) in 2007 to that in 2010?
Provide a succinct answer. 1.03. What is the ratio of the Unemployed and educated labor force (% of population) in Denmark in 2007 to that in 2010?
Make the answer very short. 1.02. What is the ratio of the Unemployed and educated labor force (% of population) in Latvia in 2007 to that in 2010?
Keep it short and to the point. 1.37. What is the ratio of the Unemployed and educated labor force (% of population) in Lithuania in 2007 to that in 2010?
Your answer should be very brief. 1.11. What is the ratio of the Unemployed and educated labor force (% of population) in Europe(developing only) in 2008 to that in 2009?
Keep it short and to the point. 0.99. What is the ratio of the Unemployed and educated labor force (% of population) in Denmark in 2008 to that in 2009?
Offer a very short reply. 1.06. What is the ratio of the Unemployed and educated labor force (% of population) in Latvia in 2008 to that in 2009?
Your answer should be very brief. 1.13. What is the ratio of the Unemployed and educated labor force (% of population) of Lithuania in 2008 to that in 2009?
Provide a succinct answer. 1. What is the ratio of the Unemployed and educated labor force (% of population) in Europe(developing only) in 2008 to that in 2010?
Your answer should be compact. 1.02. What is the ratio of the Unemployed and educated labor force (% of population) of Denmark in 2008 to that in 2010?
Give a very brief answer. 1.14. What is the ratio of the Unemployed and educated labor force (% of population) of Latvia in 2008 to that in 2010?
Offer a terse response. 1.31. What is the ratio of the Unemployed and educated labor force (% of population) of Lithuania in 2008 to that in 2010?
Your response must be concise. 1.11. What is the ratio of the Unemployed and educated labor force (% of population) of Europe(developing only) in 2009 to that in 2010?
Your answer should be compact. 1.03. What is the ratio of the Unemployed and educated labor force (% of population) of Denmark in 2009 to that in 2010?
Provide a succinct answer. 1.07. What is the ratio of the Unemployed and educated labor force (% of population) of Latvia in 2009 to that in 2010?
Provide a succinct answer. 1.16. What is the ratio of the Unemployed and educated labor force (% of population) in Lithuania in 2009 to that in 2010?
Ensure brevity in your answer.  1.11. What is the difference between the highest and the second highest Unemployed and educated labor force (% of population) of Europe(developing only)?
Provide a short and direct response. 0.03. What is the difference between the highest and the second highest Unemployed and educated labor force (% of population) of Latvia?
Provide a short and direct response. 5.8. What is the difference between the highest and the second highest Unemployed and educated labor force (% of population) in Lithuania?
Your answer should be very brief. 0.3. What is the difference between the highest and the lowest Unemployed and educated labor force (% of population) in Europe(developing only)?
Your response must be concise. 1.17. What is the difference between the highest and the lowest Unemployed and educated labor force (% of population) in Latvia?
Make the answer very short. 12.7. What is the difference between the highest and the lowest Unemployed and educated labor force (% of population) in Lithuania?
Provide a short and direct response. 2.9. 